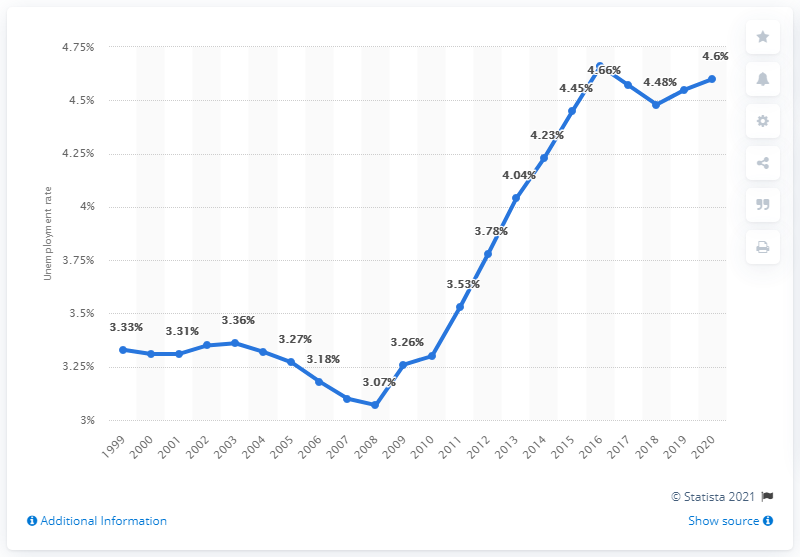Mention a couple of crucial points in this snapshot. In 2020, the unemployment rate in Timor-Leste was 4.6%. 